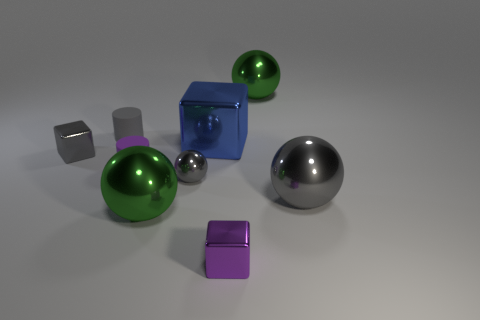How many things are in front of the large green object on the left side of the ball that is behind the small purple rubber cylinder?
Make the answer very short. 1. There is a cylinder that is the same color as the tiny metallic sphere; what is its size?
Your answer should be very brief. Small. Is there a big brown block made of the same material as the blue object?
Provide a short and direct response. No. Is the purple cube made of the same material as the tiny purple cylinder?
Make the answer very short. No. There is a small gray metal object on the left side of the purple matte cylinder; how many tiny matte cylinders are on the left side of it?
Make the answer very short. 0. How many brown objects are cylinders or small metal objects?
Offer a terse response. 0. There is a gray object that is on the right side of the green shiny object that is behind the purple matte thing in front of the large blue metal thing; what is its shape?
Your answer should be very brief. Sphere. The other matte cylinder that is the same size as the purple cylinder is what color?
Your answer should be compact. Gray. How many large blue objects are the same shape as the large gray thing?
Offer a very short reply. 0. Does the purple rubber cylinder have the same size as the gray object that is on the right side of the small purple metallic cube?
Make the answer very short. No. 